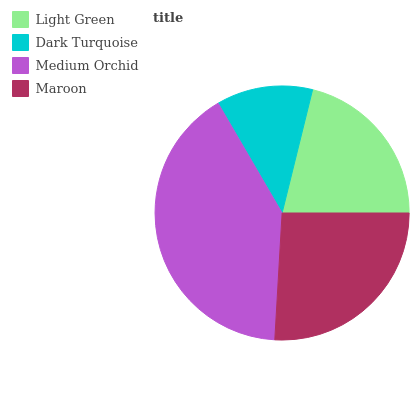Is Dark Turquoise the minimum?
Answer yes or no. Yes. Is Medium Orchid the maximum?
Answer yes or no. Yes. Is Medium Orchid the minimum?
Answer yes or no. No. Is Dark Turquoise the maximum?
Answer yes or no. No. Is Medium Orchid greater than Dark Turquoise?
Answer yes or no. Yes. Is Dark Turquoise less than Medium Orchid?
Answer yes or no. Yes. Is Dark Turquoise greater than Medium Orchid?
Answer yes or no. No. Is Medium Orchid less than Dark Turquoise?
Answer yes or no. No. Is Maroon the high median?
Answer yes or no. Yes. Is Light Green the low median?
Answer yes or no. Yes. Is Medium Orchid the high median?
Answer yes or no. No. Is Dark Turquoise the low median?
Answer yes or no. No. 